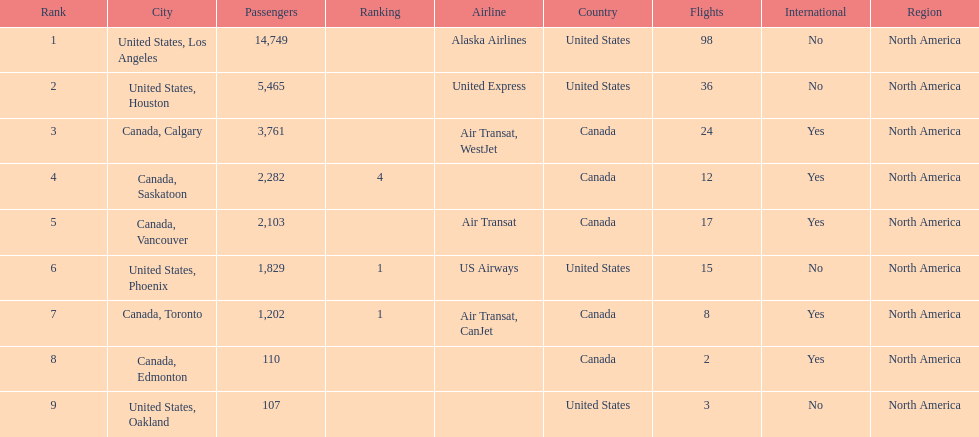The least number of passengers came from which city United States, Oakland. 